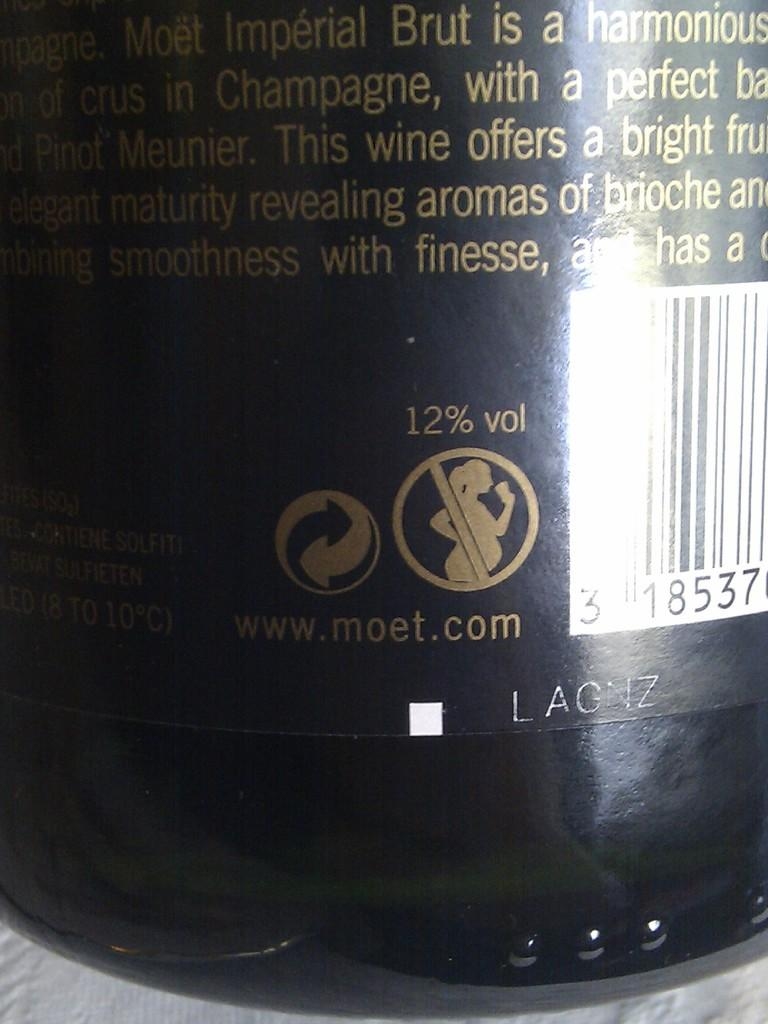<image>
Create a compact narrative representing the image presented. Bottle with a label that says LAGNZ on the bottom. 